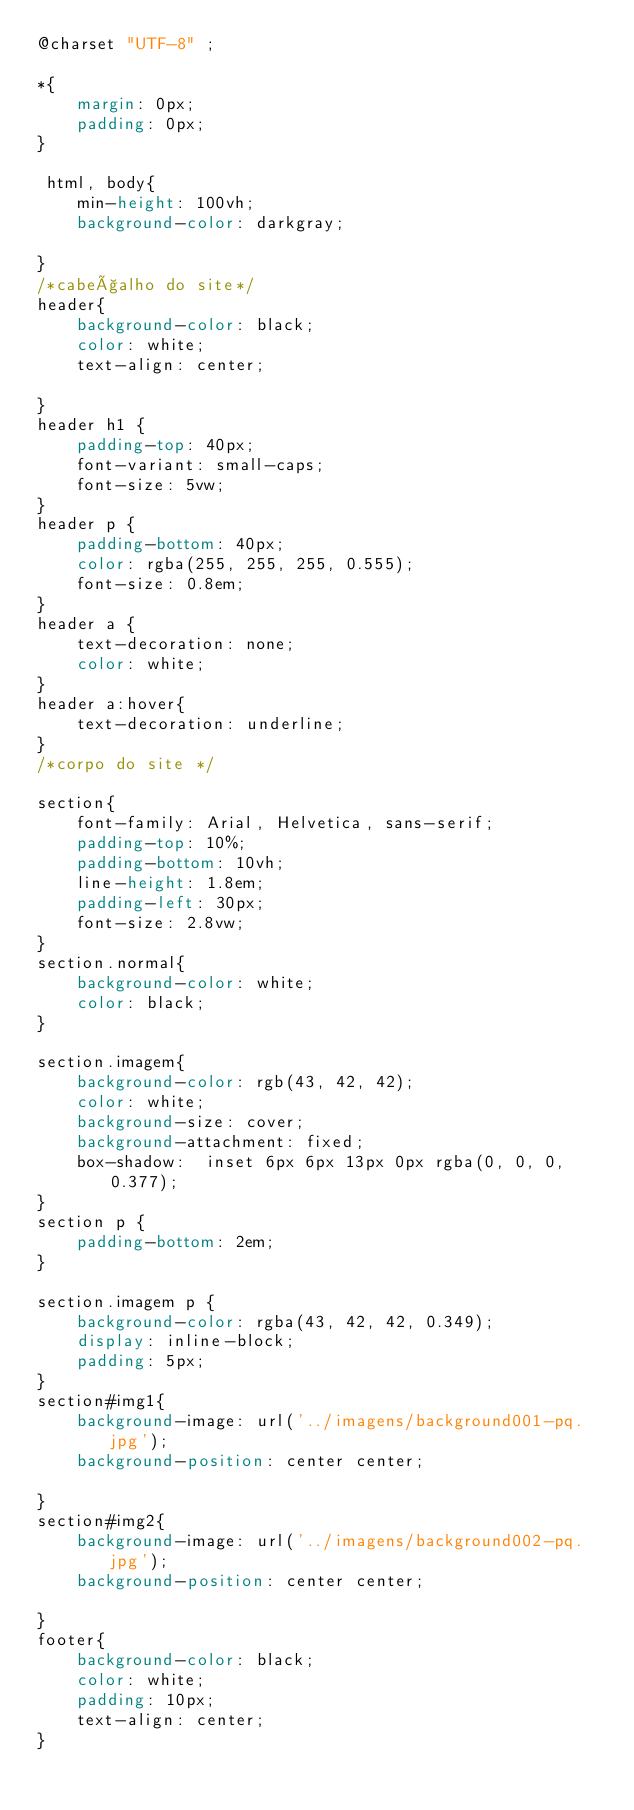Convert code to text. <code><loc_0><loc_0><loc_500><loc_500><_CSS_>@charset "UTF-8" ;

*{
    margin: 0px;
    padding: 0px;
}

 html, body{
    min-height: 100vh;
    background-color: darkgray;

}
/*cabeçalho do site*/
header{
    background-color: black;
    color: white;
    text-align: center;

}
header h1 {
    padding-top: 40px;
    font-variant: small-caps;
    font-size: 5vw;
}
header p {
    padding-bottom: 40px;
    color: rgba(255, 255, 255, 0.555);
    font-size: 0.8em;
}
header a {
    text-decoration: none;
    color: white;
} 
header a:hover{
    text-decoration: underline;
}
/*corpo do site */

section{
    font-family: Arial, Helvetica, sans-serif;
    padding-top: 10%;
    padding-bottom: 10vh;
    line-height: 1.8em;
    padding-left: 30px;
    font-size: 2.8vw;
}
section.normal{
    background-color: white;
    color: black;
}

section.imagem{
    background-color: rgb(43, 42, 42);
    color: white;
    background-size: cover;
    background-attachment: fixed;
    box-shadow:  inset 6px 6px 13px 0px rgba(0, 0, 0, 0.377);
}
section p {
    padding-bottom: 2em;
}

section.imagem p {
    background-color: rgba(43, 42, 42, 0.349);
    display: inline-block;
    padding: 5px;
}
section#img1{
    background-image: url('../imagens/background001-pq.jpg');
    background-position: center center;

}
section#img2{
    background-image: url('../imagens/background002-pq.jpg');
    background-position: center center;
    
}
footer{
    background-color: black;
    color: white;
    padding: 10px;
    text-align: center;
}

</code> 